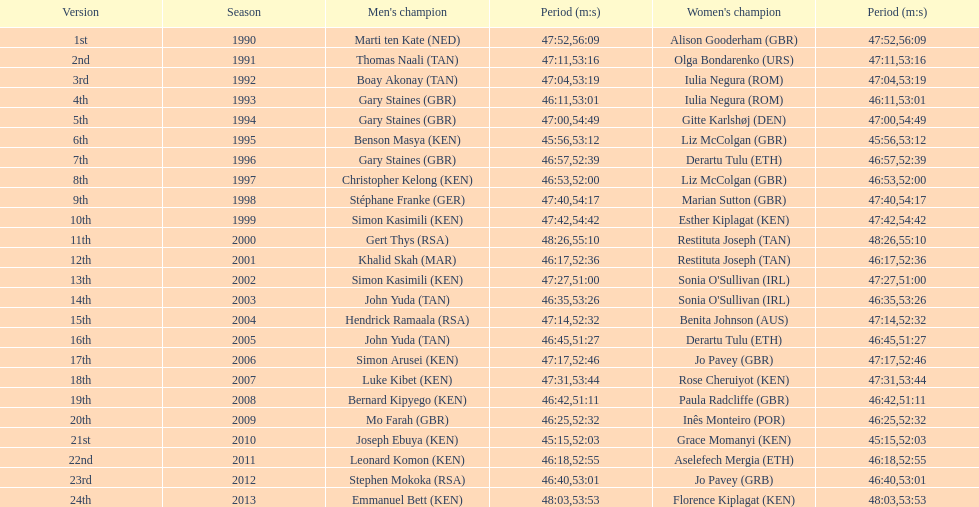What is the appellation of the earliest women's winner? Alison Gooderham. 